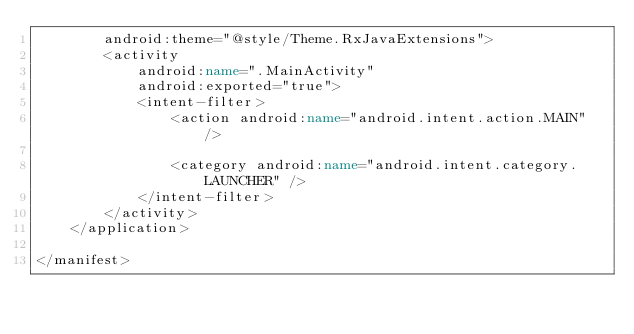<code> <loc_0><loc_0><loc_500><loc_500><_XML_>        android:theme="@style/Theme.RxJavaExtensions">
        <activity
            android:name=".MainActivity"
            android:exported="true">
            <intent-filter>
                <action android:name="android.intent.action.MAIN" />

                <category android:name="android.intent.category.LAUNCHER" />
            </intent-filter>
        </activity>
    </application>

</manifest>
</code> 